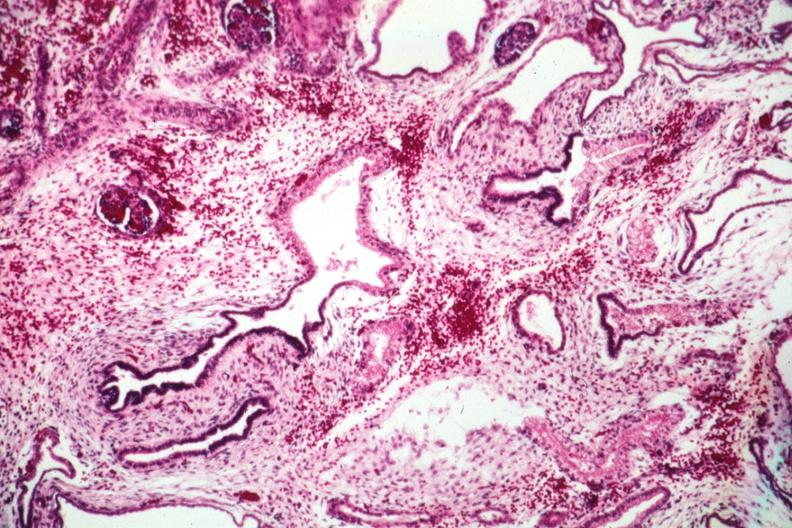s kidney present?
Answer the question using a single word or phrase. Yes 